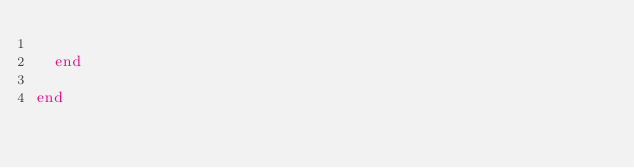<code> <loc_0><loc_0><loc_500><loc_500><_Crystal_>
  end

end
</code> 